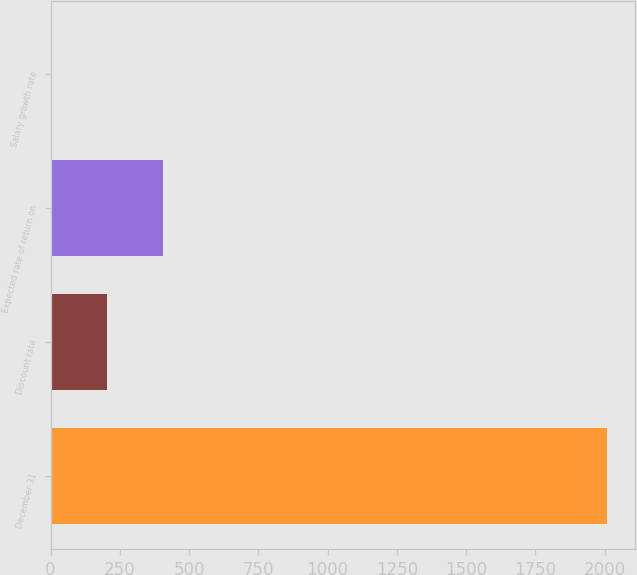Convert chart to OTSL. <chart><loc_0><loc_0><loc_500><loc_500><bar_chart><fcel>December 31<fcel>Discount rate<fcel>Expected rate of return on<fcel>Salary growth rate<nl><fcel>2009<fcel>204.95<fcel>405.4<fcel>4.5<nl></chart> 